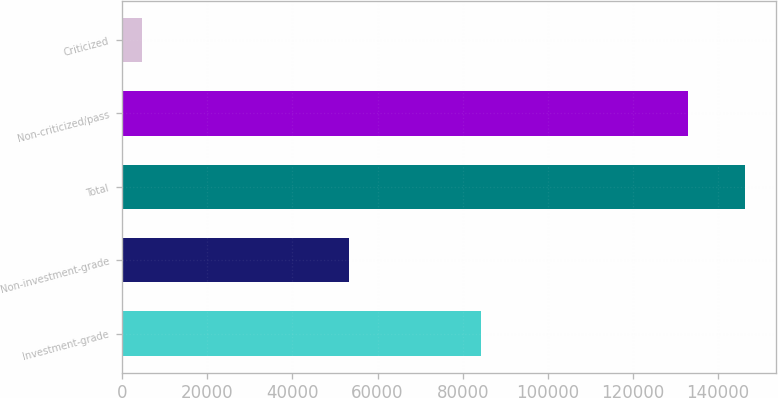Convert chart to OTSL. <chart><loc_0><loc_0><loc_500><loc_500><bar_chart><fcel>Investment-grade<fcel>Non-investment-grade<fcel>Total<fcel>Non-criticized/pass<fcel>Criticized<nl><fcel>84357<fcel>53262<fcel>146287<fcel>132988<fcel>4631<nl></chart> 